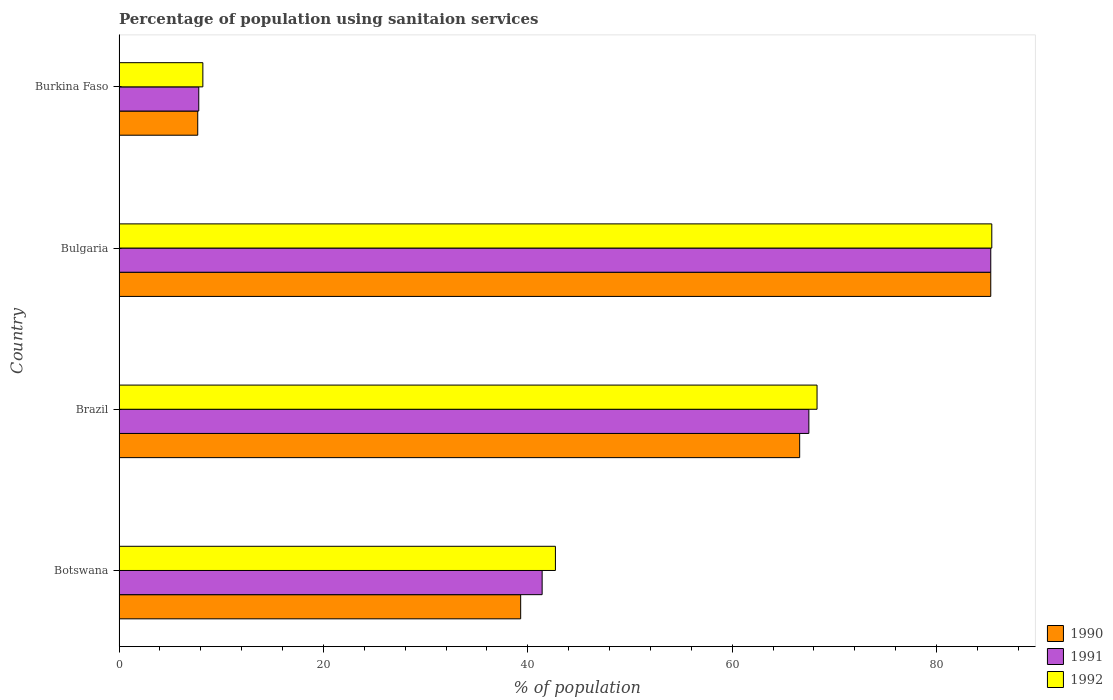How many different coloured bars are there?
Your answer should be compact. 3. Are the number of bars per tick equal to the number of legend labels?
Provide a short and direct response. Yes. Are the number of bars on each tick of the Y-axis equal?
Ensure brevity in your answer.  Yes. How many bars are there on the 4th tick from the top?
Make the answer very short. 3. How many bars are there on the 1st tick from the bottom?
Offer a terse response. 3. What is the label of the 4th group of bars from the top?
Your answer should be very brief. Botswana. What is the percentage of population using sanitaion services in 1990 in Brazil?
Offer a very short reply. 66.6. Across all countries, what is the maximum percentage of population using sanitaion services in 1992?
Provide a succinct answer. 85.4. Across all countries, what is the minimum percentage of population using sanitaion services in 1991?
Ensure brevity in your answer.  7.8. In which country was the percentage of population using sanitaion services in 1992 minimum?
Provide a short and direct response. Burkina Faso. What is the total percentage of population using sanitaion services in 1991 in the graph?
Provide a short and direct response. 202. What is the difference between the percentage of population using sanitaion services in 1992 in Brazil and that in Burkina Faso?
Keep it short and to the point. 60.1. What is the average percentage of population using sanitaion services in 1990 per country?
Ensure brevity in your answer.  49.72. What is the difference between the percentage of population using sanitaion services in 1991 and percentage of population using sanitaion services in 1990 in Botswana?
Keep it short and to the point. 2.1. What is the ratio of the percentage of population using sanitaion services in 1990 in Bulgaria to that in Burkina Faso?
Your response must be concise. 11.08. What is the difference between the highest and the second highest percentage of population using sanitaion services in 1992?
Provide a succinct answer. 17.1. What is the difference between the highest and the lowest percentage of population using sanitaion services in 1991?
Give a very brief answer. 77.5. What does the 1st bar from the top in Botswana represents?
Your answer should be compact. 1992. Are all the bars in the graph horizontal?
Make the answer very short. Yes. How many countries are there in the graph?
Ensure brevity in your answer.  4. Are the values on the major ticks of X-axis written in scientific E-notation?
Keep it short and to the point. No. Does the graph contain any zero values?
Ensure brevity in your answer.  No. Where does the legend appear in the graph?
Provide a short and direct response. Bottom right. How are the legend labels stacked?
Offer a very short reply. Vertical. What is the title of the graph?
Provide a short and direct response. Percentage of population using sanitaion services. Does "1997" appear as one of the legend labels in the graph?
Provide a succinct answer. No. What is the label or title of the X-axis?
Make the answer very short. % of population. What is the label or title of the Y-axis?
Offer a terse response. Country. What is the % of population in 1990 in Botswana?
Provide a short and direct response. 39.3. What is the % of population of 1991 in Botswana?
Offer a very short reply. 41.4. What is the % of population of 1992 in Botswana?
Offer a terse response. 42.7. What is the % of population of 1990 in Brazil?
Your answer should be very brief. 66.6. What is the % of population in 1991 in Brazil?
Keep it short and to the point. 67.5. What is the % of population of 1992 in Brazil?
Offer a terse response. 68.3. What is the % of population of 1990 in Bulgaria?
Offer a terse response. 85.3. What is the % of population in 1991 in Bulgaria?
Keep it short and to the point. 85.3. What is the % of population of 1992 in Bulgaria?
Offer a terse response. 85.4. What is the % of population in 1990 in Burkina Faso?
Keep it short and to the point. 7.7. Across all countries, what is the maximum % of population of 1990?
Provide a short and direct response. 85.3. Across all countries, what is the maximum % of population of 1991?
Your answer should be very brief. 85.3. Across all countries, what is the maximum % of population of 1992?
Make the answer very short. 85.4. Across all countries, what is the minimum % of population in 1990?
Offer a terse response. 7.7. What is the total % of population of 1990 in the graph?
Offer a very short reply. 198.9. What is the total % of population of 1991 in the graph?
Keep it short and to the point. 202. What is the total % of population of 1992 in the graph?
Keep it short and to the point. 204.6. What is the difference between the % of population of 1990 in Botswana and that in Brazil?
Make the answer very short. -27.3. What is the difference between the % of population in 1991 in Botswana and that in Brazil?
Your answer should be compact. -26.1. What is the difference between the % of population in 1992 in Botswana and that in Brazil?
Make the answer very short. -25.6. What is the difference between the % of population of 1990 in Botswana and that in Bulgaria?
Give a very brief answer. -46. What is the difference between the % of population in 1991 in Botswana and that in Bulgaria?
Offer a terse response. -43.9. What is the difference between the % of population in 1992 in Botswana and that in Bulgaria?
Give a very brief answer. -42.7. What is the difference between the % of population of 1990 in Botswana and that in Burkina Faso?
Your answer should be very brief. 31.6. What is the difference between the % of population in 1991 in Botswana and that in Burkina Faso?
Your answer should be compact. 33.6. What is the difference between the % of population in 1992 in Botswana and that in Burkina Faso?
Make the answer very short. 34.5. What is the difference between the % of population in 1990 in Brazil and that in Bulgaria?
Your response must be concise. -18.7. What is the difference between the % of population of 1991 in Brazil and that in Bulgaria?
Provide a short and direct response. -17.8. What is the difference between the % of population of 1992 in Brazil and that in Bulgaria?
Give a very brief answer. -17.1. What is the difference between the % of population of 1990 in Brazil and that in Burkina Faso?
Make the answer very short. 58.9. What is the difference between the % of population of 1991 in Brazil and that in Burkina Faso?
Provide a succinct answer. 59.7. What is the difference between the % of population of 1992 in Brazil and that in Burkina Faso?
Ensure brevity in your answer.  60.1. What is the difference between the % of population in 1990 in Bulgaria and that in Burkina Faso?
Keep it short and to the point. 77.6. What is the difference between the % of population in 1991 in Bulgaria and that in Burkina Faso?
Make the answer very short. 77.5. What is the difference between the % of population in 1992 in Bulgaria and that in Burkina Faso?
Offer a very short reply. 77.2. What is the difference between the % of population in 1990 in Botswana and the % of population in 1991 in Brazil?
Offer a terse response. -28.2. What is the difference between the % of population of 1991 in Botswana and the % of population of 1992 in Brazil?
Ensure brevity in your answer.  -26.9. What is the difference between the % of population in 1990 in Botswana and the % of population in 1991 in Bulgaria?
Your response must be concise. -46. What is the difference between the % of population of 1990 in Botswana and the % of population of 1992 in Bulgaria?
Provide a short and direct response. -46.1. What is the difference between the % of population in 1991 in Botswana and the % of population in 1992 in Bulgaria?
Make the answer very short. -44. What is the difference between the % of population in 1990 in Botswana and the % of population in 1991 in Burkina Faso?
Ensure brevity in your answer.  31.5. What is the difference between the % of population of 1990 in Botswana and the % of population of 1992 in Burkina Faso?
Make the answer very short. 31.1. What is the difference between the % of population in 1991 in Botswana and the % of population in 1992 in Burkina Faso?
Your answer should be very brief. 33.2. What is the difference between the % of population in 1990 in Brazil and the % of population in 1991 in Bulgaria?
Your answer should be very brief. -18.7. What is the difference between the % of population in 1990 in Brazil and the % of population in 1992 in Bulgaria?
Offer a very short reply. -18.8. What is the difference between the % of population in 1991 in Brazil and the % of population in 1992 in Bulgaria?
Provide a succinct answer. -17.9. What is the difference between the % of population in 1990 in Brazil and the % of population in 1991 in Burkina Faso?
Give a very brief answer. 58.8. What is the difference between the % of population of 1990 in Brazil and the % of population of 1992 in Burkina Faso?
Ensure brevity in your answer.  58.4. What is the difference between the % of population of 1991 in Brazil and the % of population of 1992 in Burkina Faso?
Give a very brief answer. 59.3. What is the difference between the % of population of 1990 in Bulgaria and the % of population of 1991 in Burkina Faso?
Give a very brief answer. 77.5. What is the difference between the % of population of 1990 in Bulgaria and the % of population of 1992 in Burkina Faso?
Provide a succinct answer. 77.1. What is the difference between the % of population in 1991 in Bulgaria and the % of population in 1992 in Burkina Faso?
Keep it short and to the point. 77.1. What is the average % of population of 1990 per country?
Give a very brief answer. 49.73. What is the average % of population in 1991 per country?
Your answer should be compact. 50.5. What is the average % of population of 1992 per country?
Offer a very short reply. 51.15. What is the difference between the % of population in 1990 and % of population in 1991 in Botswana?
Your response must be concise. -2.1. What is the difference between the % of population of 1991 and % of population of 1992 in Botswana?
Your answer should be compact. -1.3. What is the difference between the % of population of 1990 and % of population of 1991 in Brazil?
Make the answer very short. -0.9. What is the difference between the % of population of 1990 and % of population of 1992 in Brazil?
Your answer should be very brief. -1.7. What is the difference between the % of population in 1990 and % of population in 1991 in Bulgaria?
Provide a succinct answer. 0. What is the difference between the % of population in 1991 and % of population in 1992 in Burkina Faso?
Offer a terse response. -0.4. What is the ratio of the % of population in 1990 in Botswana to that in Brazil?
Offer a very short reply. 0.59. What is the ratio of the % of population of 1991 in Botswana to that in Brazil?
Your answer should be compact. 0.61. What is the ratio of the % of population in 1992 in Botswana to that in Brazil?
Give a very brief answer. 0.63. What is the ratio of the % of population of 1990 in Botswana to that in Bulgaria?
Keep it short and to the point. 0.46. What is the ratio of the % of population in 1991 in Botswana to that in Bulgaria?
Give a very brief answer. 0.49. What is the ratio of the % of population in 1990 in Botswana to that in Burkina Faso?
Your response must be concise. 5.1. What is the ratio of the % of population of 1991 in Botswana to that in Burkina Faso?
Your answer should be very brief. 5.31. What is the ratio of the % of population of 1992 in Botswana to that in Burkina Faso?
Provide a succinct answer. 5.21. What is the ratio of the % of population of 1990 in Brazil to that in Bulgaria?
Your answer should be compact. 0.78. What is the ratio of the % of population of 1991 in Brazil to that in Bulgaria?
Your answer should be very brief. 0.79. What is the ratio of the % of population of 1992 in Brazil to that in Bulgaria?
Your response must be concise. 0.8. What is the ratio of the % of population of 1990 in Brazil to that in Burkina Faso?
Give a very brief answer. 8.65. What is the ratio of the % of population of 1991 in Brazil to that in Burkina Faso?
Provide a succinct answer. 8.65. What is the ratio of the % of population of 1992 in Brazil to that in Burkina Faso?
Your response must be concise. 8.33. What is the ratio of the % of population in 1990 in Bulgaria to that in Burkina Faso?
Provide a succinct answer. 11.08. What is the ratio of the % of population in 1991 in Bulgaria to that in Burkina Faso?
Keep it short and to the point. 10.94. What is the ratio of the % of population in 1992 in Bulgaria to that in Burkina Faso?
Offer a very short reply. 10.41. What is the difference between the highest and the second highest % of population of 1990?
Give a very brief answer. 18.7. What is the difference between the highest and the second highest % of population in 1992?
Make the answer very short. 17.1. What is the difference between the highest and the lowest % of population of 1990?
Give a very brief answer. 77.6. What is the difference between the highest and the lowest % of population of 1991?
Provide a short and direct response. 77.5. What is the difference between the highest and the lowest % of population of 1992?
Offer a very short reply. 77.2. 